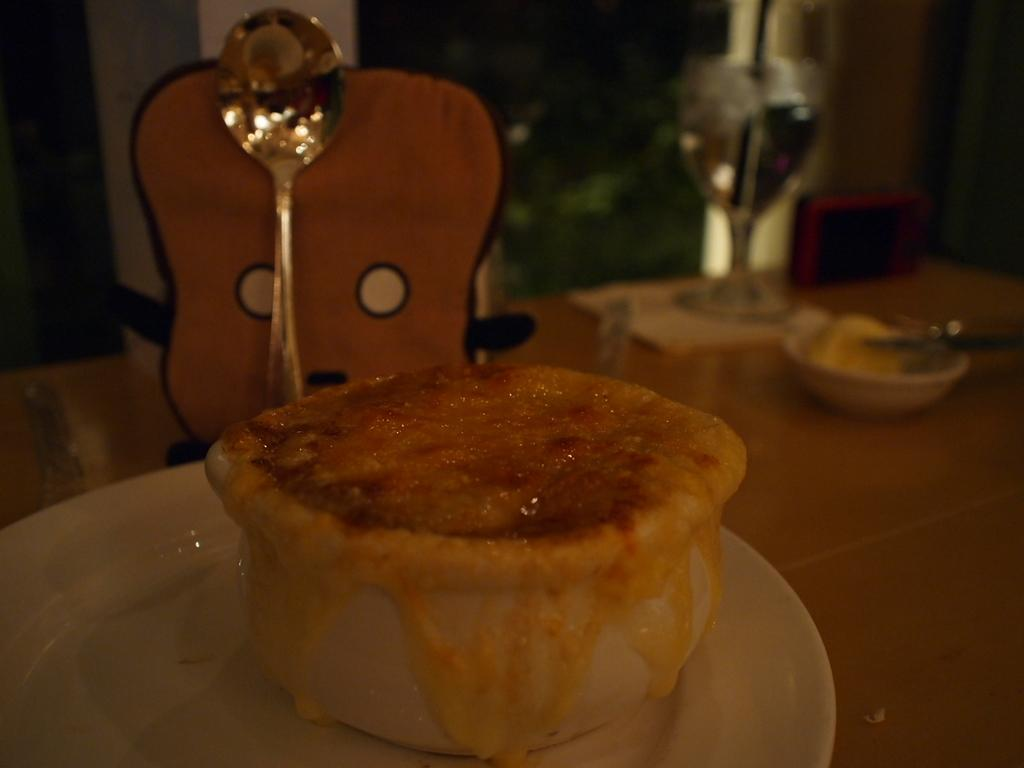What is the main object in the center of the image? There is a table in the center of the image. What can be found on the table? On the table, there is a plate, a spoon, a glass, and bowls. What type of items are on the table? There are food items and a few other objects on the table. How does the page turn itself in the image? There is no page present in the image. What type of transport is used to move the food items in the image? There is no transport visible in the image; the food items are stationary on the table. 